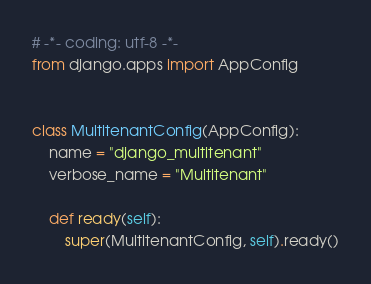<code> <loc_0><loc_0><loc_500><loc_500><_Python_># -*- coding: utf-8 -*-
from django.apps import AppConfig


class MultitenantConfig(AppConfig):
    name = "django_multitenant"
    verbose_name = "Multitenant"

    def ready(self):
        super(MultitenantConfig, self).ready()
</code> 